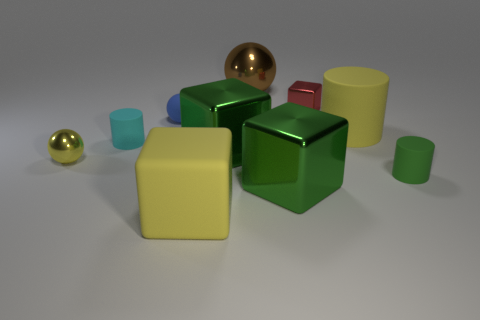Subtract 1 cubes. How many cubes are left? 3 Subtract all green cylinders. Subtract all cyan blocks. How many cylinders are left? 2 Subtract all cylinders. How many objects are left? 7 Add 8 small brown things. How many small brown things exist? 8 Subtract 0 purple cubes. How many objects are left? 10 Subtract all cyan matte cylinders. Subtract all cyan cylinders. How many objects are left? 8 Add 4 large brown metal spheres. How many large brown metal spheres are left? 5 